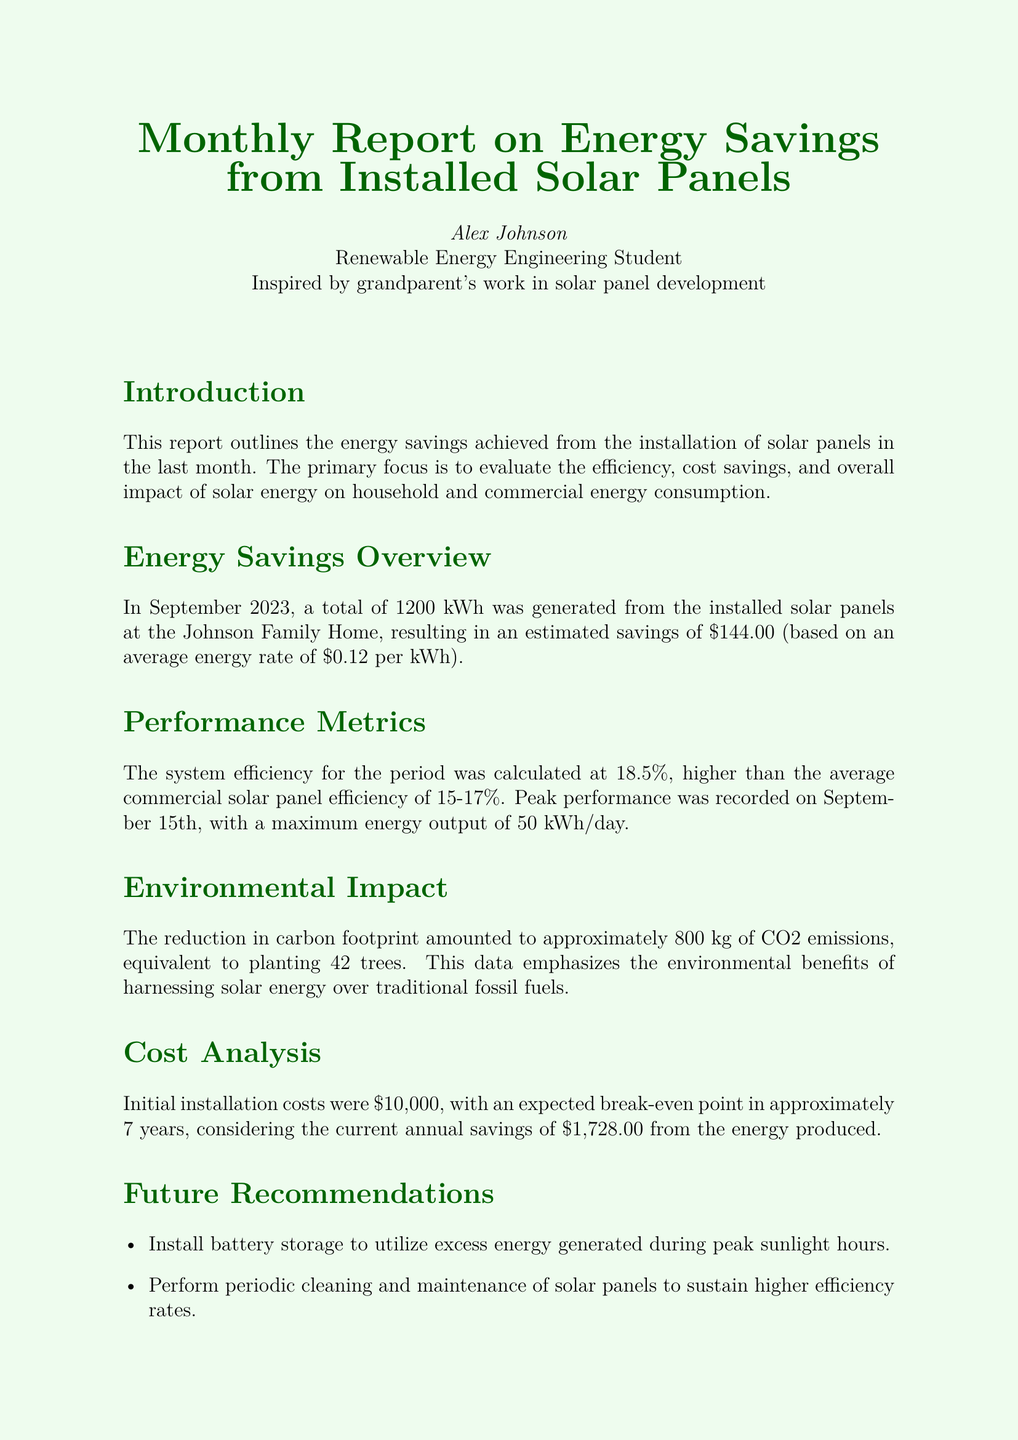What was the total energy generated in September 2023? The document states that a total of 1200 kWh was generated from the installed solar panels in September 2023.
Answer: 1200 kWh What was the savings amount for September 2023? The report mentions an estimated savings of $144.00 based on the generated energy.
Answer: $144.00 What was the peak performance date? The document mentions that peak performance was recorded on September 15th.
Answer: September 15th What is the estimated break-even point for installation costs? The estimated break-even point mentioned in the report is approximately 7 years.
Answer: 7 years How much CO2 emissions were reduced? The report indicates that the reduction in carbon footprint amounted to approximately 800 kg of CO2 emissions.
Answer: 800 kg What is the system efficiency achieved? The system efficiency calculated for the period was 18.5%.
Answer: 18.5% How many trees is the CO2 reduction equivalent to? The document states that the CO2 reduction is equivalent to planting 42 trees.
Answer: 42 trees What is one recommendation for future improvements? The report suggests installing battery storage to utilize excess energy generated.
Answer: Install battery storage 